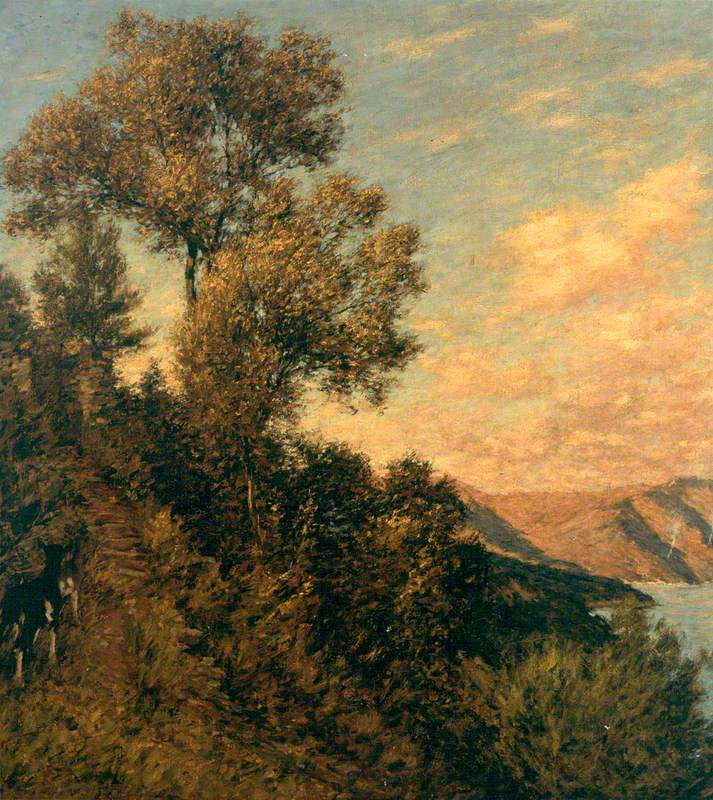What is this photo about'?
 The image is a captivating representation of a landscape, painted in the impressionist style. The scene is dominated by a tree perched on a cliff, its leaves a rich, dark green that contrasts with the lighter hues of the sky and water. The body of water, possibly a lake or river, mirrors the light orange of the sky, suggesting either a sunrise or sunset. The loose brushstrokes characteristic of impressionism lend a sense of movement and life to the scene. Given the style and subject matter, it's likely that this painting originates from the 19th century, a period when landscape painting was a popular genre. The overall composition and color palette evoke a sense of tranquility and harmony with nature. 